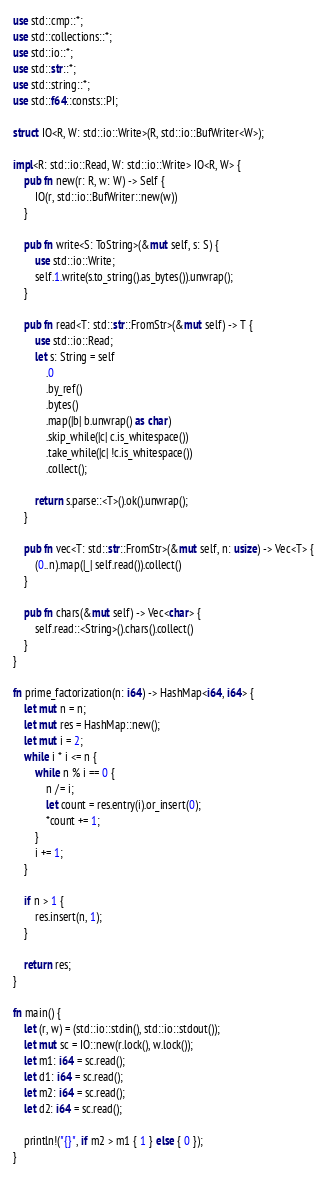<code> <loc_0><loc_0><loc_500><loc_500><_Rust_>use std::cmp::*;
use std::collections::*;
use std::io::*;
use std::str::*;
use std::string::*;
use std::f64::consts::PI;

struct IO<R, W: std::io::Write>(R, std::io::BufWriter<W>);

impl<R: std::io::Read, W: std::io::Write> IO<R, W> {
    pub fn new(r: R, w: W) -> Self {
        IO(r, std::io::BufWriter::new(w))
    }

    pub fn write<S: ToString>(&mut self, s: S) {
        use std::io::Write;
        self.1.write(s.to_string().as_bytes()).unwrap();
    }

    pub fn read<T: std::str::FromStr>(&mut self) -> T {
        use std::io::Read;
        let s: String = self
            .0
            .by_ref()
            .bytes()
            .map(|b| b.unwrap() as char)
            .skip_while(|c| c.is_whitespace())
            .take_while(|c| !c.is_whitespace())
            .collect();

        return s.parse::<T>().ok().unwrap();
    }

    pub fn vec<T: std::str::FromStr>(&mut self, n: usize) -> Vec<T> {
        (0..n).map(|_| self.read()).collect()
    }

    pub fn chars(&mut self) -> Vec<char> {
        self.read::<String>().chars().collect()
    }
}

fn prime_factorization(n: i64) -> HashMap<i64, i64> {
    let mut n = n;
    let mut res = HashMap::new();
    let mut i = 2;
    while i * i <= n {
        while n % i == 0 {
            n /= i;
            let count = res.entry(i).or_insert(0);
            *count += 1;
        }
        i += 1;
    }

    if n > 1 {
        res.insert(n, 1);
    }

    return res;
}

fn main() {
    let (r, w) = (std::io::stdin(), std::io::stdout());
    let mut sc = IO::new(r.lock(), w.lock());
    let m1: i64 = sc.read();
    let d1: i64 = sc.read();
    let m2: i64 = sc.read();
    let d2: i64 = sc.read();

    println!("{}", if m2 > m1 { 1 } else { 0 });
}
</code> 